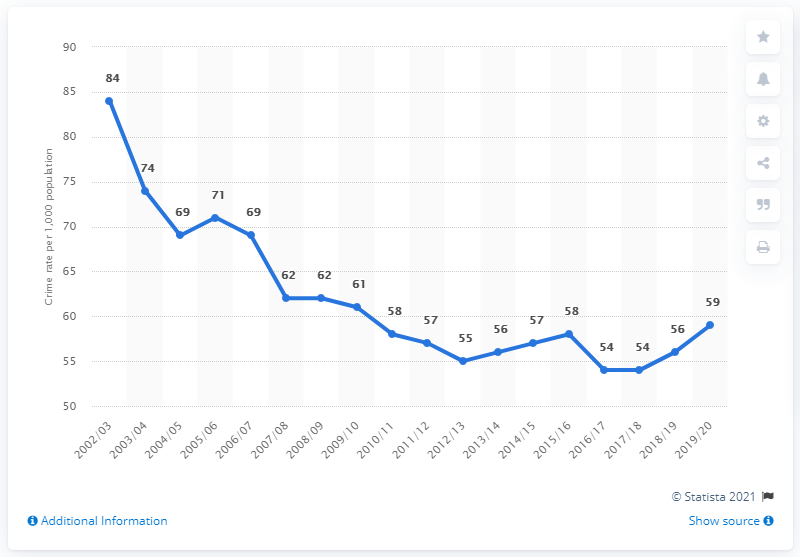What was Northern Ireland's crime rate in 2019/20? In 2019/20, Northern Ireland had a reported crime rate of approximately 59 incidents per 1,000 population, according to the provided chart from Statista. This figure represents a slight increase compared to the previous year 2018/19, which showed a crime rate of 56 incidents per 1,000 population. 